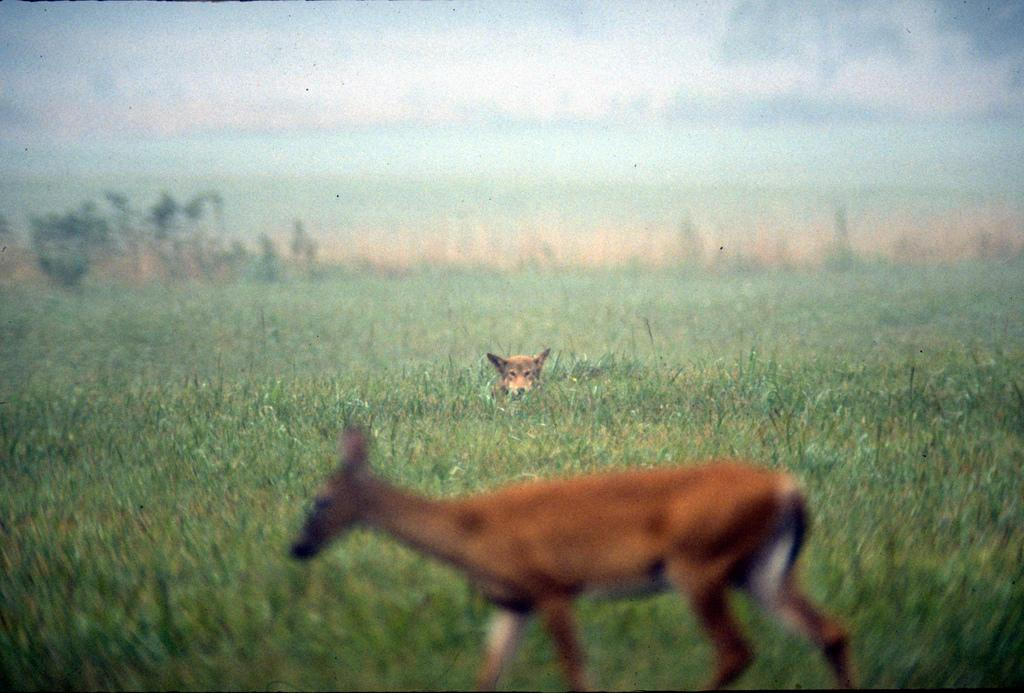How many animals can be seen in the image? There are two animals in the image. What type of vegetation is present in the image? There is grass in the image. Can you describe the quality of the image? The image is slightly blurry. Is there a volcano visible in the image? No, there is no volcano present in the image. What time of day is depicted in the image? The provided facts do not give information about the time of day, so it cannot be determined from the image. 